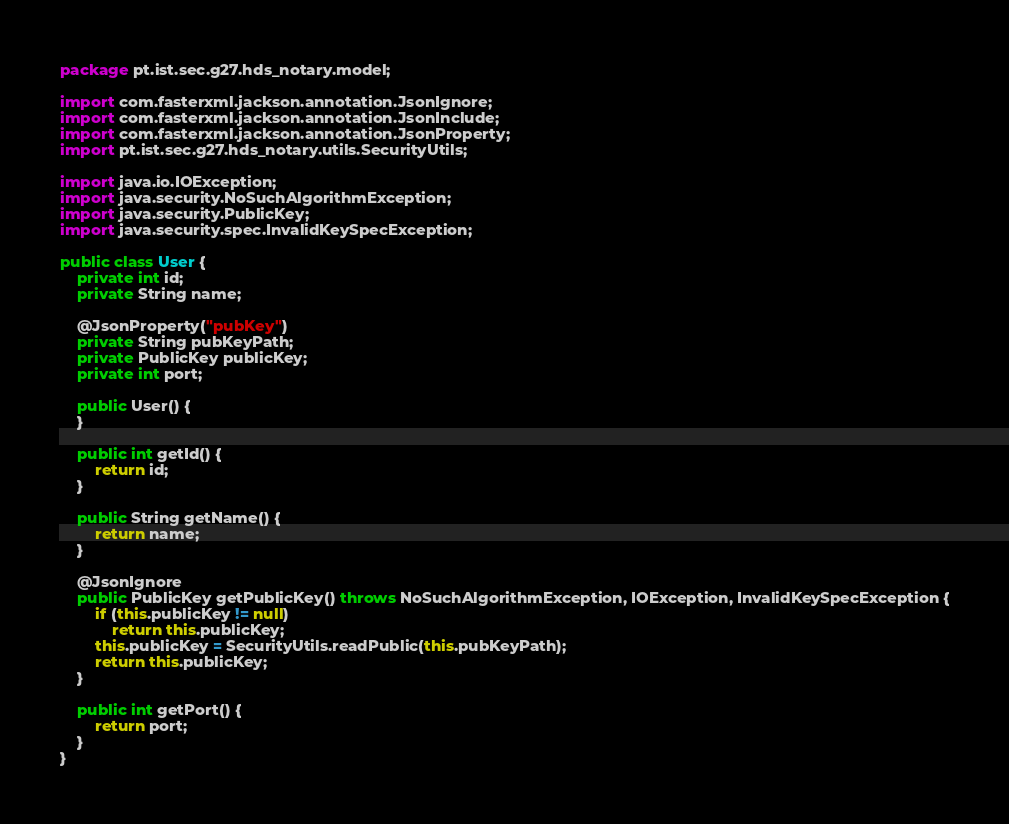<code> <loc_0><loc_0><loc_500><loc_500><_Java_>package pt.ist.sec.g27.hds_notary.model;

import com.fasterxml.jackson.annotation.JsonIgnore;
import com.fasterxml.jackson.annotation.JsonInclude;
import com.fasterxml.jackson.annotation.JsonProperty;
import pt.ist.sec.g27.hds_notary.utils.SecurityUtils;

import java.io.IOException;
import java.security.NoSuchAlgorithmException;
import java.security.PublicKey;
import java.security.spec.InvalidKeySpecException;

public class User {
    private int id;
    private String name;

    @JsonProperty("pubKey")
    private String pubKeyPath;
    private PublicKey publicKey;
    private int port;

    public User() {
    }

    public int getId() {
        return id;
    }

    public String getName() {
        return name;
    }

    @JsonIgnore
    public PublicKey getPublicKey() throws NoSuchAlgorithmException, IOException, InvalidKeySpecException {
        if (this.publicKey != null)
            return this.publicKey;
        this.publicKey = SecurityUtils.readPublic(this.pubKeyPath);
        return this.publicKey;
    }

    public int getPort() {
        return port;
    }
}
</code> 